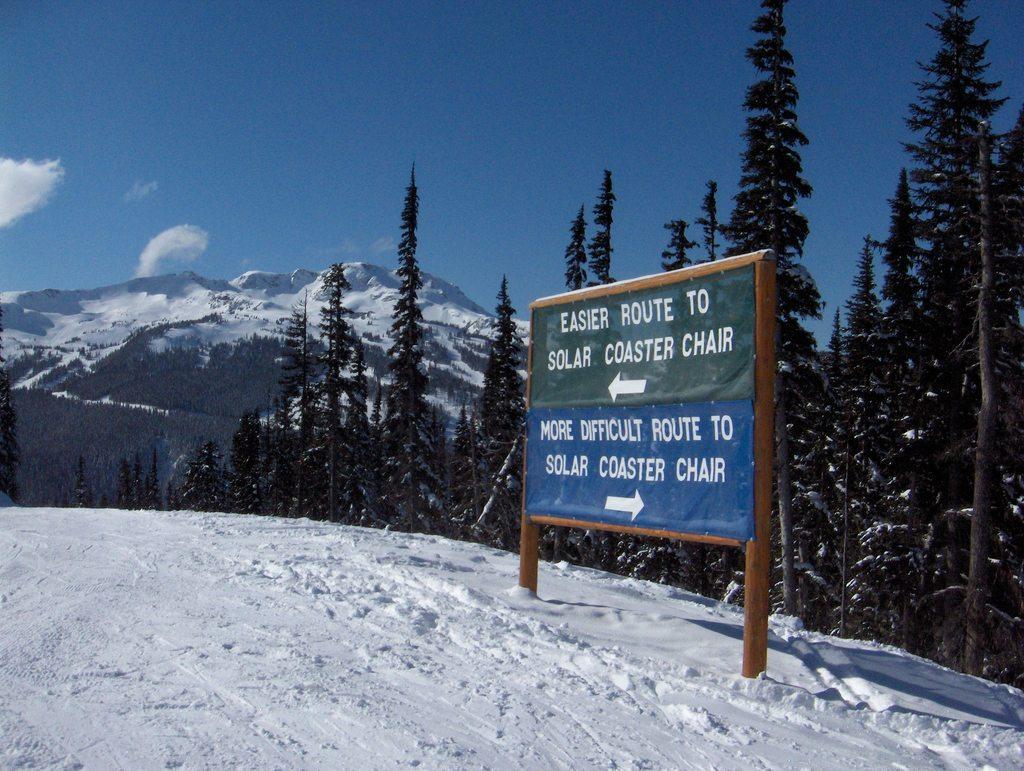Please provide a concise description of this image. In this picture there is a mountain and there are trees. In the foreground there is a board and there is text on the board. At the top there is sky and there are clouds. At the bottom there is snow. 